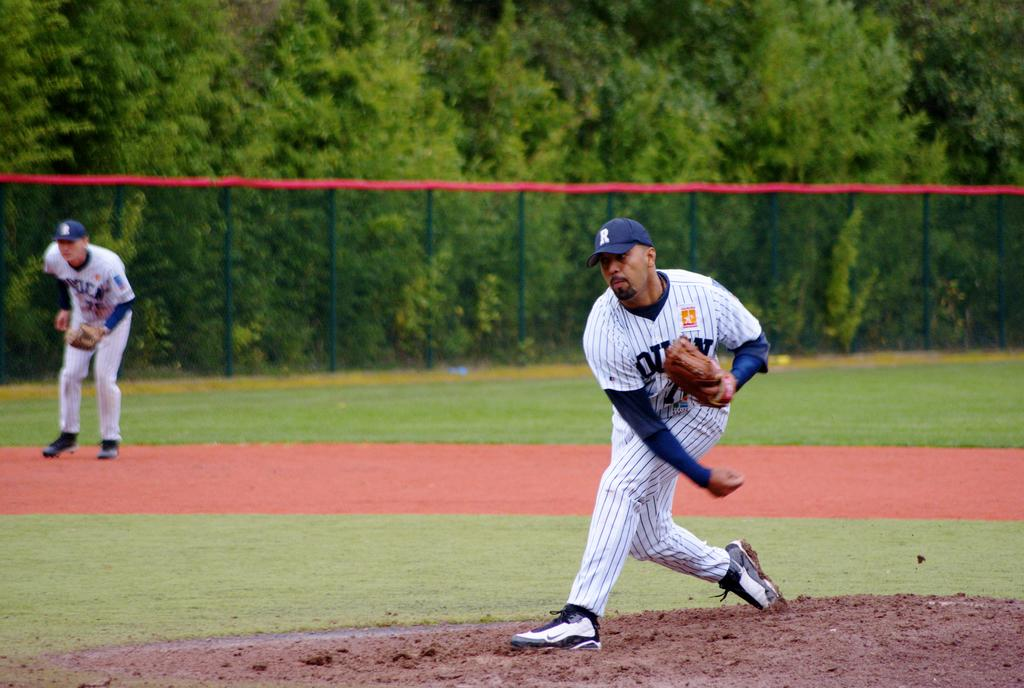<image>
Provide a brief description of the given image. A man with an R on his hat has just thrown a baseball. 